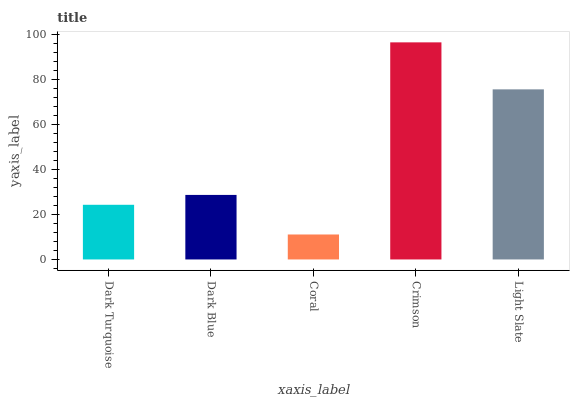Is Coral the minimum?
Answer yes or no. Yes. Is Crimson the maximum?
Answer yes or no. Yes. Is Dark Blue the minimum?
Answer yes or no. No. Is Dark Blue the maximum?
Answer yes or no. No. Is Dark Blue greater than Dark Turquoise?
Answer yes or no. Yes. Is Dark Turquoise less than Dark Blue?
Answer yes or no. Yes. Is Dark Turquoise greater than Dark Blue?
Answer yes or no. No. Is Dark Blue less than Dark Turquoise?
Answer yes or no. No. Is Dark Blue the high median?
Answer yes or no. Yes. Is Dark Blue the low median?
Answer yes or no. Yes. Is Light Slate the high median?
Answer yes or no. No. Is Dark Turquoise the low median?
Answer yes or no. No. 